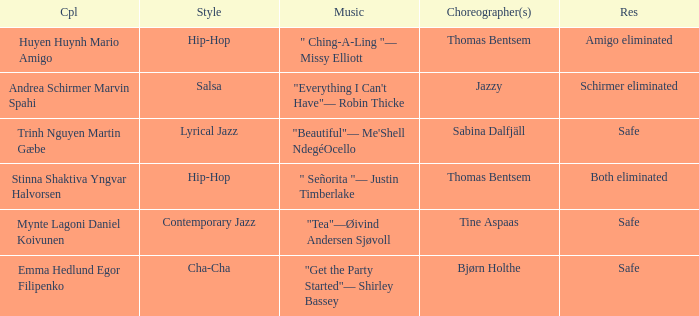What has choreographer bjørn holthe achieved in his career? Safe. 